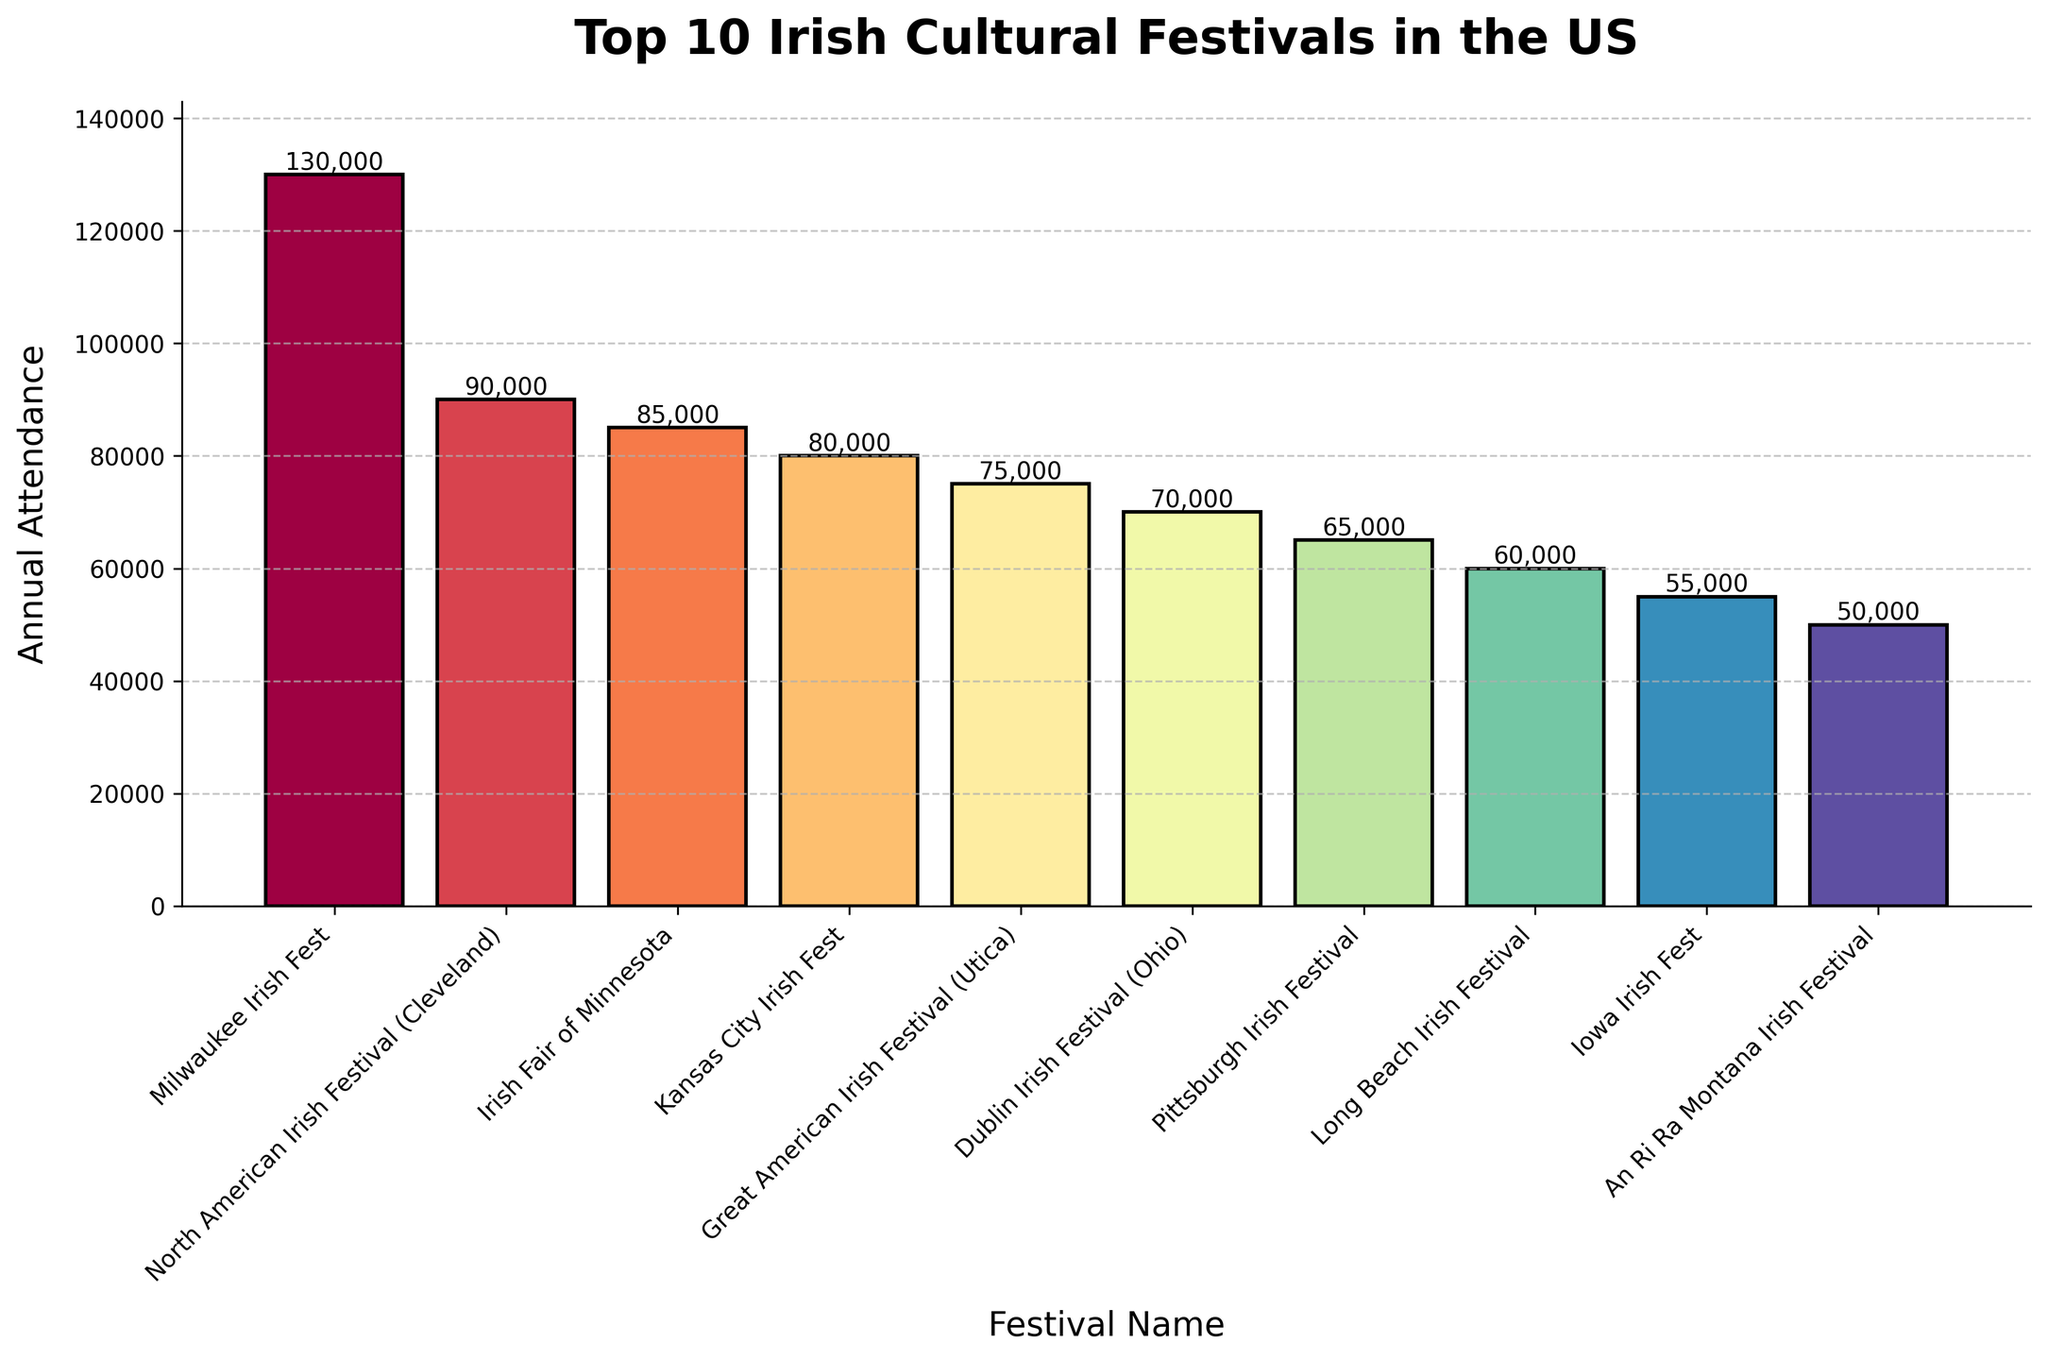Which festival has the highest annual attendance? The bar chart shows that the Milwaukee Irish Fest has the tallest bar, indicating the highest attendance.
Answer: Milwaukee Irish Fest How many more attendees does the Milwaukee Irish Fest have compared to the An Ri Ra Montana Irish Festival? The Milwaukee Irish Fest has 130,000 attendees, and the An Ri Ra Montana Irish Festival has 50,000 attendees. The difference in attendance is 130,000 - 50,000 = 80,000.
Answer: 80,000 Are there more people attending the Kansas City Irish Fest or the Irish Fair of Minnesota? The bar chart shows the Irish Fair of Minnesota has an attendance of 85,000, which is greater than the Kansas City Irish Fest's 80,000 attendees.
Answer: Irish Fair of Minnesota Which two festivals have the closest attendance numbers, and what are those numbers? By examining the heights of the bars, the Dublin Irish Festival (70,000) and the Pittsburgh Irish Festival (65,000) have the closest attendance numbers.
Answer: Dublin Irish Festival and Pittsburgh Irish Festival What is the combined attendance of the three least attended festivals on the chart? The three least attended festivals are An Ri Ra Montana Irish Festival (50,000), Iowa Irish Fest (55,000), and Long Beach Irish Festival (60,000). Their combined attendance is 50,000 + 55,000 + 60,000 = 165,000.
Answer: 165,000 Which festival’s attendance is represented by the bar colored the darkest shade? The color gradient in the bar chart suggests that Milwaukee Irish Fest, having the highest attendance, would be represented by the darkest shade.
Answer: Milwaukee Irish Fest How does the attendance of the Great American Irish Festival (Utica) compare to that of the North American Irish Festival (Cleveland)? The Great American Irish Festival has an attendance of 75,000, whereas the North American Irish Festival has 90,000 attendees. The North American Irish Festival has a higher attendance.
Answer: North American Irish Festival What is the difference in attendance between the Dublin Irish Festival and the Pittsburgh Irish Festival? The attendance for Dublin Irish Festival is 70,000, whereas Pittsburgh Irish Festival has 65,000 attendees. The difference in attendance is 70,000 - 65,000 = 5,000.
Answer: 5,000 What's the average attendance of these top 10 Irish cultural festivals? Summing the attendance figures (130,000 + 90,000 + 85,000 + 80,000 + 75,000 + 70,000 + 65,000 + 60,000 + 55,000 + 50,000) gives 760,000. Dividing by 10 gives an average attendance of 760,000 / 10 = 76,000.
Answer: 76,000 